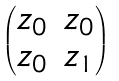Convert formula to latex. <formula><loc_0><loc_0><loc_500><loc_500>\begin{pmatrix} z _ { 0 } & z _ { 0 } \\ z _ { 0 } & z _ { 1 } \end{pmatrix}</formula> 